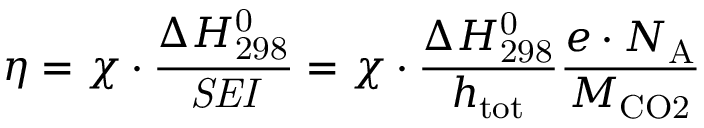<formula> <loc_0><loc_0><loc_500><loc_500>\eta = \chi \cdot \frac { \Delta H _ { 2 9 8 } ^ { 0 } } { S E I } = \chi \cdot \frac { \Delta H _ { 2 9 8 } ^ { 0 } } { h _ { t o t } } \frac { e \cdot N _ { A } } { M _ { C O 2 } }</formula> 